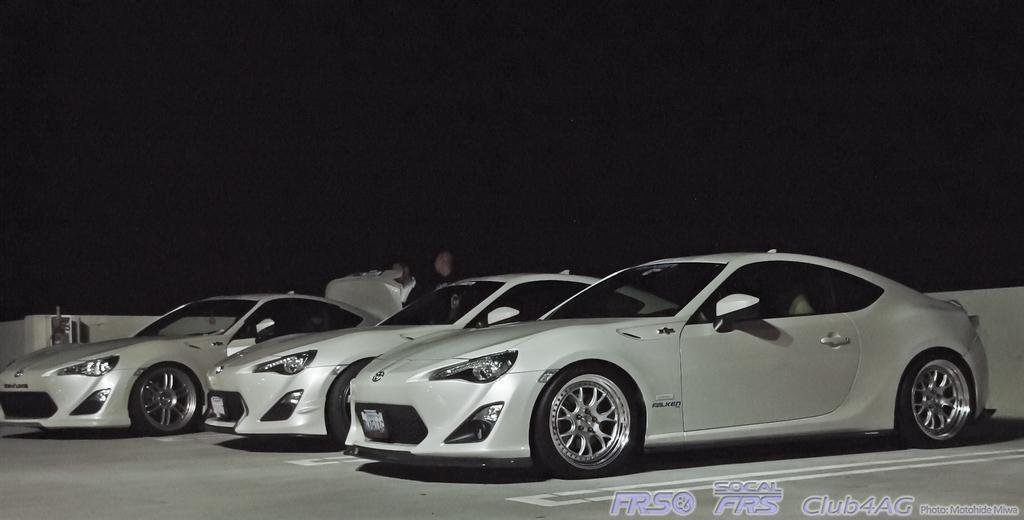In one or two sentences, can you explain what this image depicts? In this image we can see the cars parked on the path. We can also see two persons standing. In the background we can see the wall and at the bottom we can see the text. We can also see the sky. 